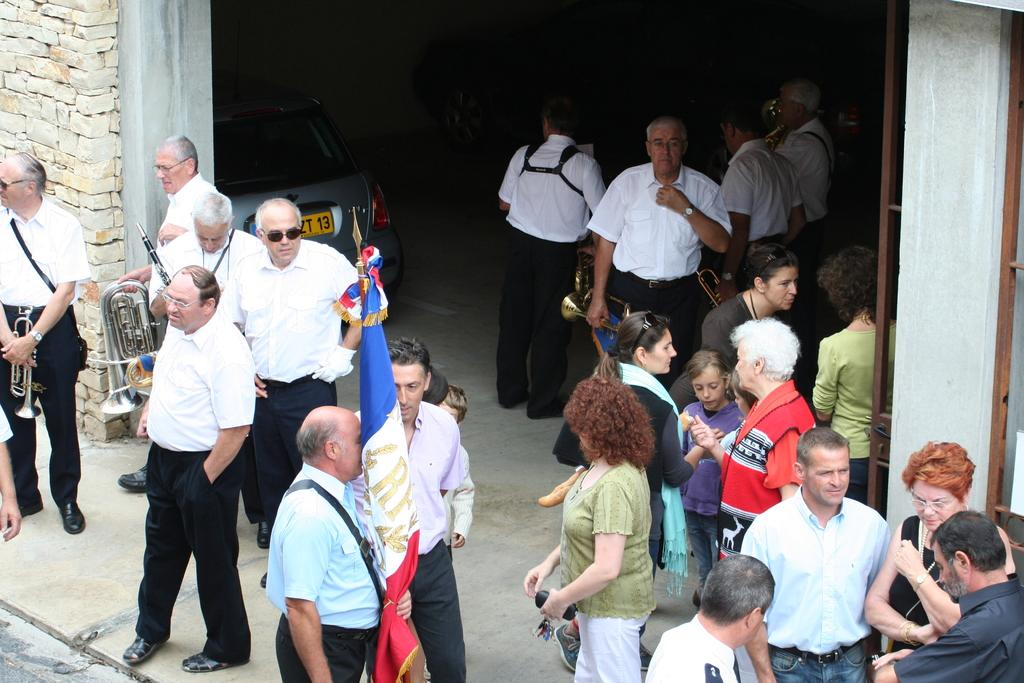How many people are in the image? There are people in the image, but the exact number is not specified. What are some of the people doing in the image? Some of the people are holding musical instruments. What type of vehicle is in the image? There is a car in the image. What kind of surface can be seen in the image? There is a path in the image. What architectural feature is present in the image? There is a wall in the image. What type of pies are being served on the wall in the image? There are no pies present in the image, and the wall is not serving any food items. What color is the sweater worn by the person playing the guitar in the image? There is no mention of a sweater or a person playing the guitar in the image. 